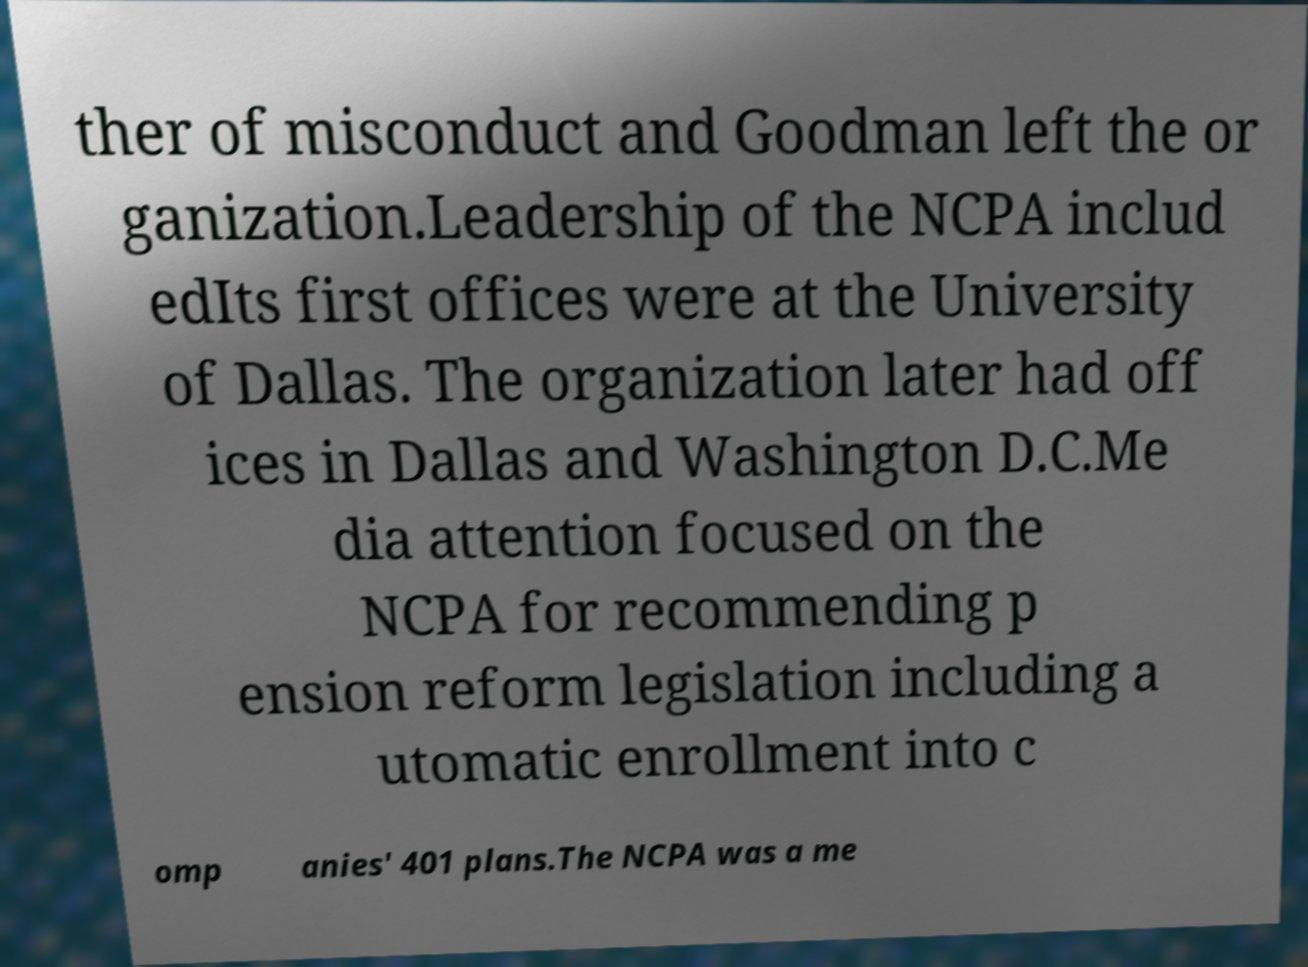I need the written content from this picture converted into text. Can you do that? ther of misconduct and Goodman left the or ganization.Leadership of the NCPA includ edIts first offices were at the University of Dallas. The organization later had off ices in Dallas and Washington D.C.Me dia attention focused on the NCPA for recommending p ension reform legislation including a utomatic enrollment into c omp anies' 401 plans.The NCPA was a me 